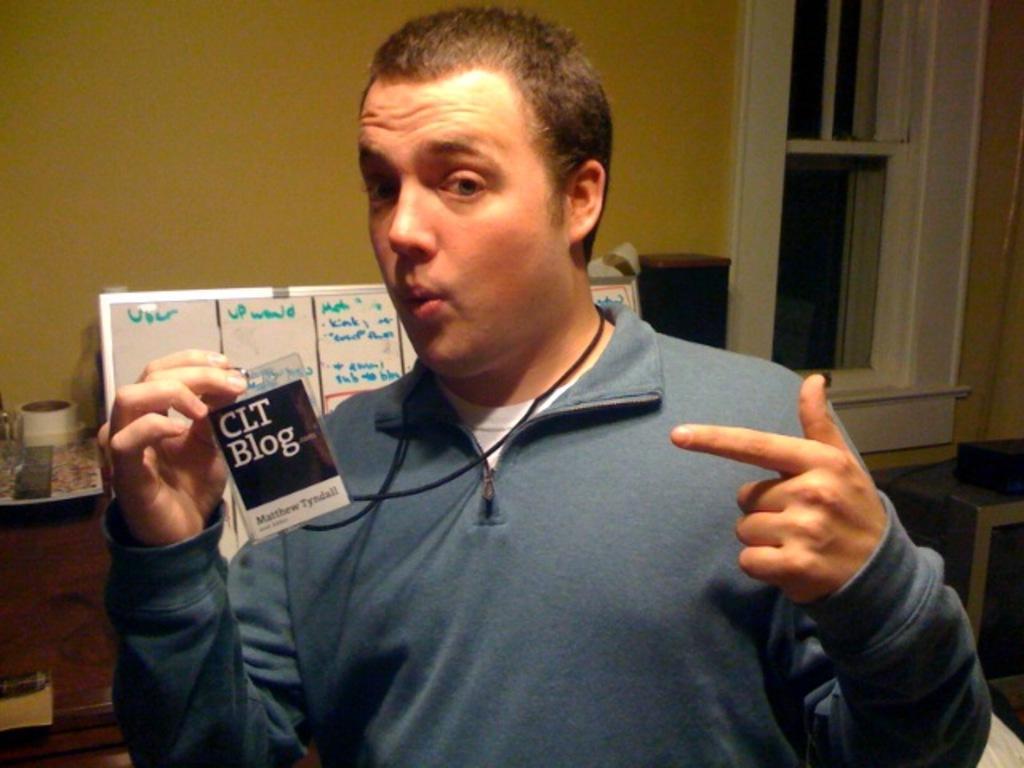Please provide a concise description of this image. In this image, we can see a man standing and he is holding an I-card. In the background, we can see a board and a wall. On the right side, we can see a window. 